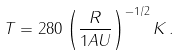<formula> <loc_0><loc_0><loc_500><loc_500>T = 2 8 0 \left ( \frac { R } { 1 A U } \right ) ^ { - 1 / 2 } K \, .</formula> 